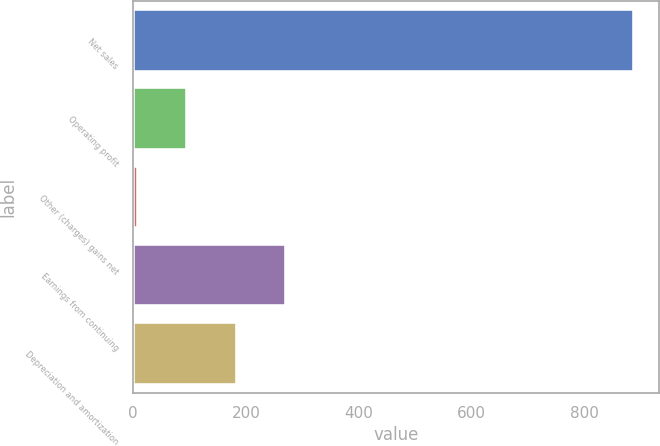Convert chart to OTSL. <chart><loc_0><loc_0><loc_500><loc_500><bar_chart><fcel>Net sales<fcel>Operating profit<fcel>Other (charges) gains net<fcel>Earnings from continuing<fcel>Depreciation and amortization<nl><fcel>887<fcel>95.9<fcel>8<fcel>271.7<fcel>183.8<nl></chart> 